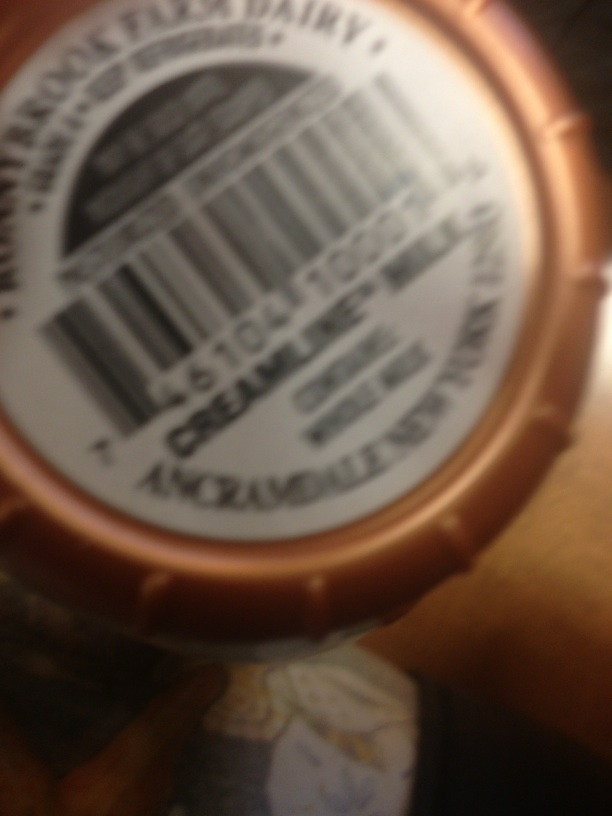What type of product is shown in this image? The image appears to show a label on a bottle or jar, suggesting it might be a food or beverage product, but the specifics are unclear due to the image's blurriness. 